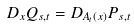Convert formula to latex. <formula><loc_0><loc_0><loc_500><loc_500>D _ { x } Q _ { s , t } = D _ { A _ { t } ( x ) } P _ { s , t }</formula> 